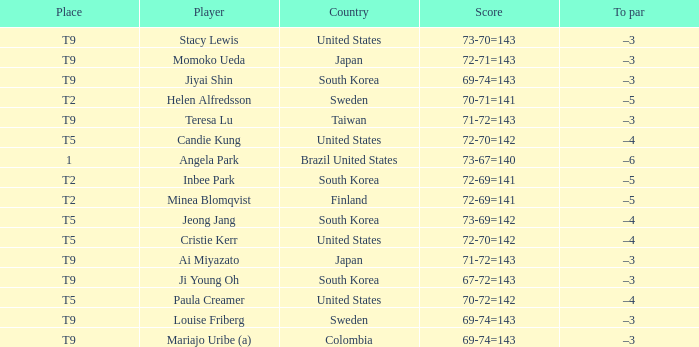What was the score for taiwan? 71-72=143. 